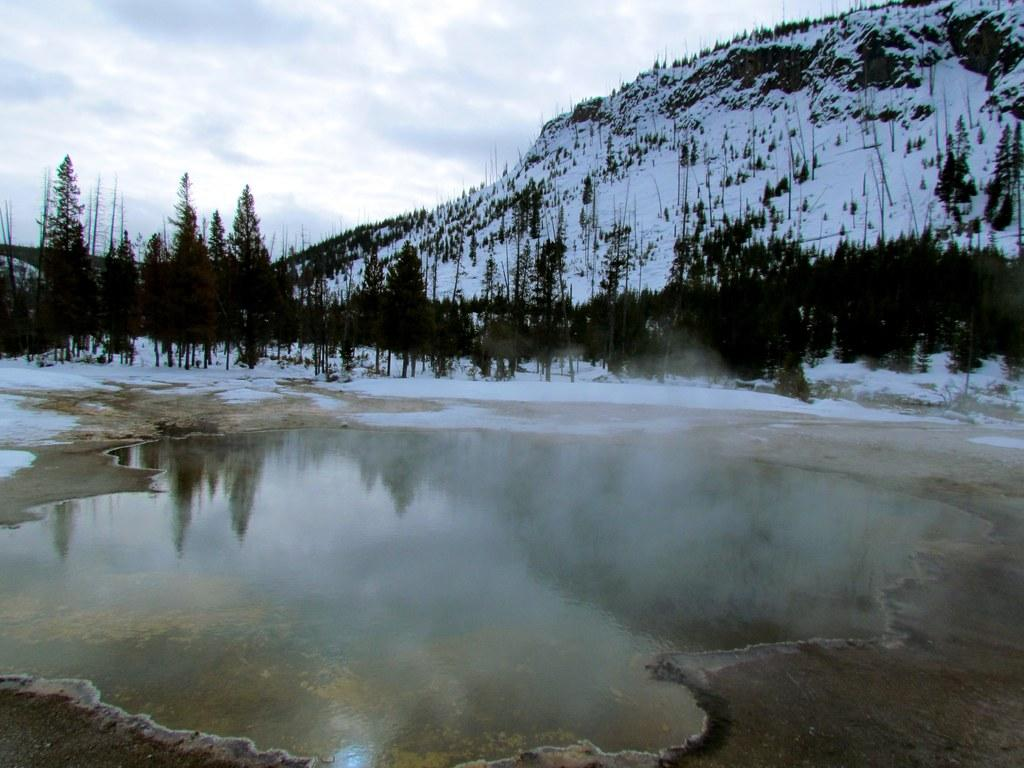What is the main subject in the center of the image? There is water in the center of the image. What can be seen in the background of the image? There is a snow mountain and trees in the background of the image. What type of clam is present in the image? There are no clams present in the image. 